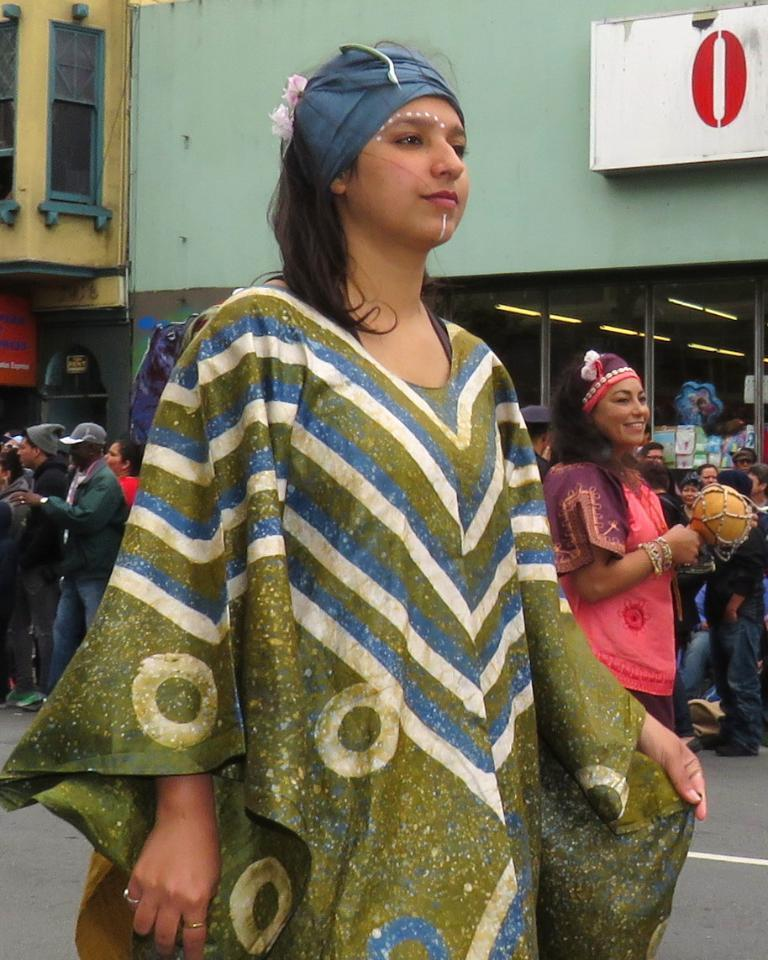What are the people in the image doing? The people in the image are standing on the road. What can be seen in the background of the image? There are buildings in the background of the image. How many bears are visible in the image? There are no bears present in the image. What type of lift is being used by the people in the image? There is no lift visible in the image, as the people are standing on the road. 